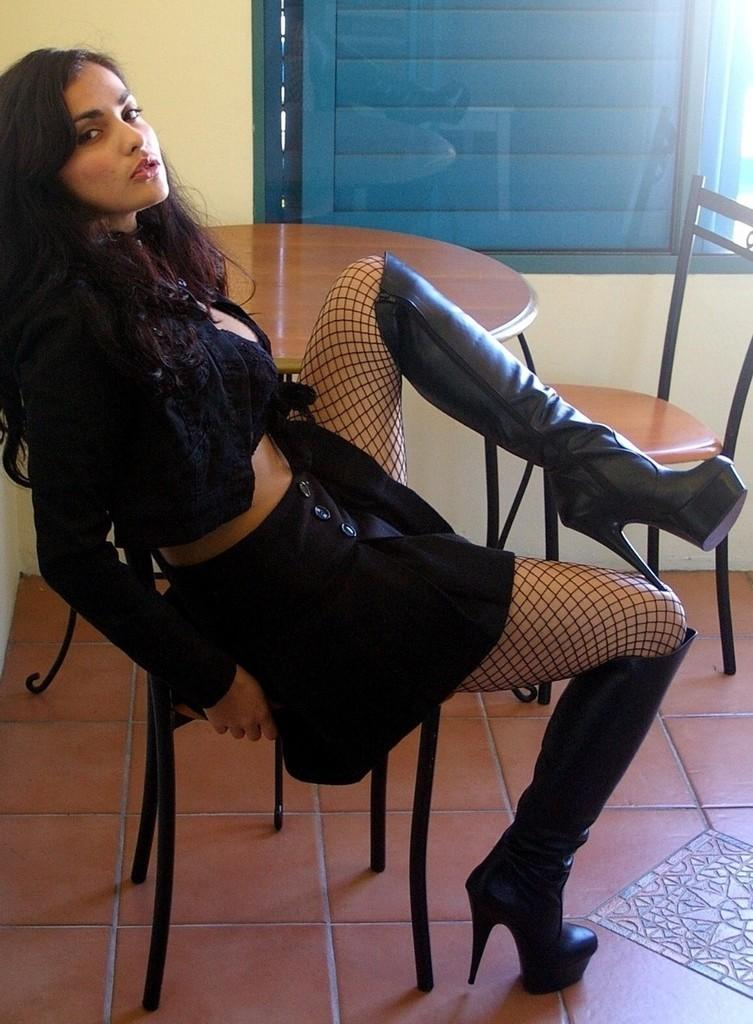Who is present in the image? There is a woman in the image. What is the woman doing in the image? The woman is seated on a chair. What other furniture is visible in the image? There is a table in the image, and there is a chair on the side of the table. Can you see a cat sleeping in the crib in the image? There is no cat or crib present in the image. 